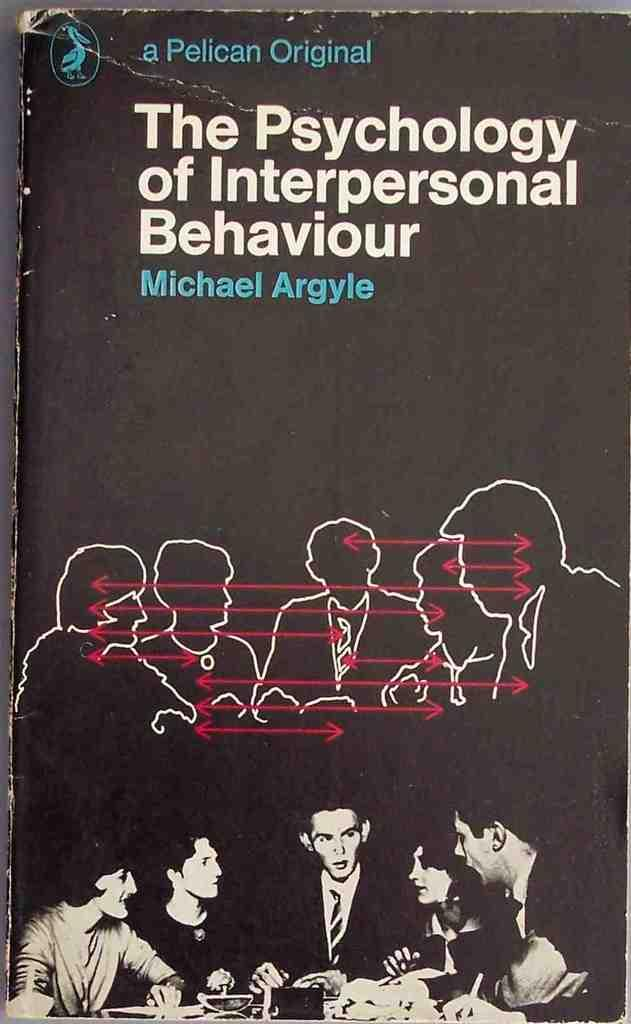What is the main subject of the image? The main subject of the image is a book. What colors are used for the text on the book? The book has white and blue color text. What type of content can be seen on the book? Images of persons are visible on the book. What type of jam is being served for breakfast on the book? There is no jam or breakfast scene depicted on the book; it only features images of persons. 